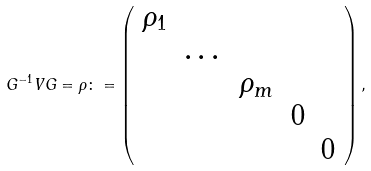Convert formula to latex. <formula><loc_0><loc_0><loc_500><loc_500>G ^ { - 1 } V G = \rho \colon = \left ( \begin{array} { c c c c c } \rho _ { 1 } & & & & \\ & \dots & & & \\ & & \rho _ { m } & & \\ & & & 0 & \\ & & & & 0 \\ \end{array} \right ) ,</formula> 